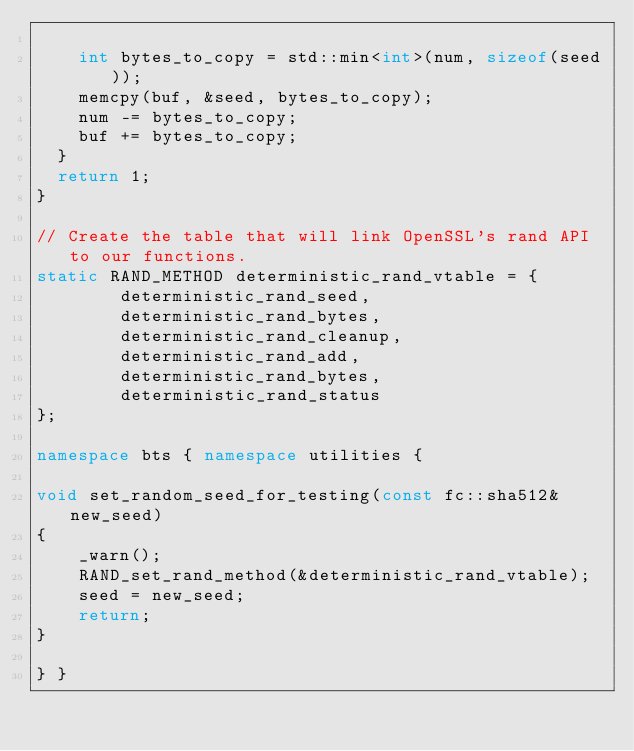Convert code to text. <code><loc_0><loc_0><loc_500><loc_500><_C++_>
    int bytes_to_copy = std::min<int>(num, sizeof(seed));
    memcpy(buf, &seed, bytes_to_copy);
    num -= bytes_to_copy;
    buf += bytes_to_copy;
  }
  return 1;
}

// Create the table that will link OpenSSL's rand API to our functions.
static RAND_METHOD deterministic_rand_vtable = {
        deterministic_rand_seed,
        deterministic_rand_bytes,
        deterministic_rand_cleanup,
        deterministic_rand_add,
        deterministic_rand_bytes,
        deterministic_rand_status
};

namespace bts { namespace utilities {

void set_random_seed_for_testing(const fc::sha512& new_seed)
{
    _warn();
    RAND_set_rand_method(&deterministic_rand_vtable);
    seed = new_seed;
    return;
}

} }
</code> 